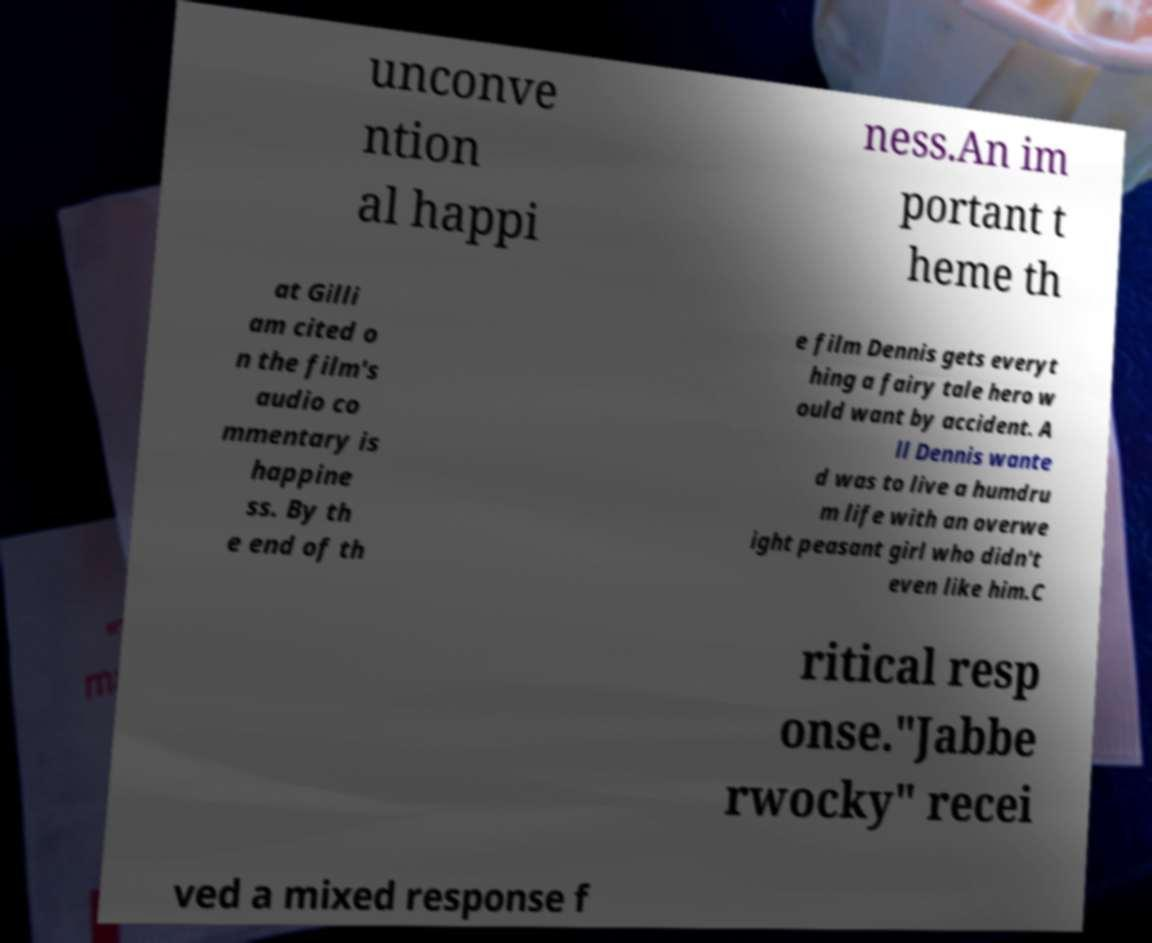There's text embedded in this image that I need extracted. Can you transcribe it verbatim? unconve ntion al happi ness.An im portant t heme th at Gilli am cited o n the film's audio co mmentary is happine ss. By th e end of th e film Dennis gets everyt hing a fairy tale hero w ould want by accident. A ll Dennis wante d was to live a humdru m life with an overwe ight peasant girl who didn't even like him.C ritical resp onse."Jabbe rwocky" recei ved a mixed response f 